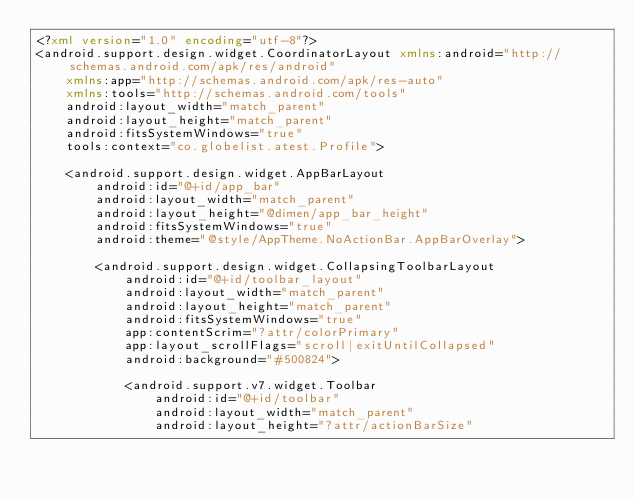Convert code to text. <code><loc_0><loc_0><loc_500><loc_500><_XML_><?xml version="1.0" encoding="utf-8"?>
<android.support.design.widget.CoordinatorLayout xmlns:android="http://schemas.android.com/apk/res/android"
    xmlns:app="http://schemas.android.com/apk/res-auto"
    xmlns:tools="http://schemas.android.com/tools"
    android:layout_width="match_parent"
    android:layout_height="match_parent"
    android:fitsSystemWindows="true"
    tools:context="co.globelist.atest.Profile">

    <android.support.design.widget.AppBarLayout
        android:id="@+id/app_bar"
        android:layout_width="match_parent"
        android:layout_height="@dimen/app_bar_height"
        android:fitsSystemWindows="true"
        android:theme="@style/AppTheme.NoActionBar.AppBarOverlay">

        <android.support.design.widget.CollapsingToolbarLayout
            android:id="@+id/toolbar_layout"
            android:layout_width="match_parent"
            android:layout_height="match_parent"
            android:fitsSystemWindows="true"
            app:contentScrim="?attr/colorPrimary"
            app:layout_scrollFlags="scroll|exitUntilCollapsed"
            android:background="#500824">

            <android.support.v7.widget.Toolbar
                android:id="@+id/toolbar"
                android:layout_width="match_parent"
                android:layout_height="?attr/actionBarSize"</code> 